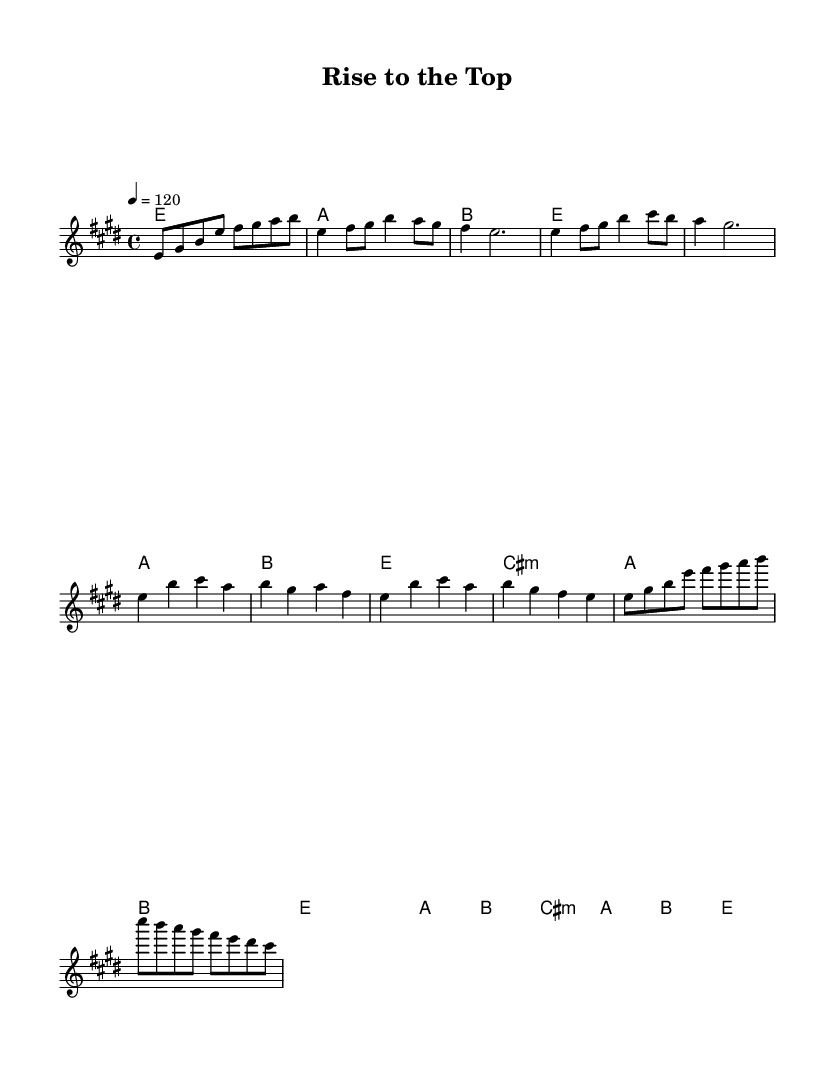What is the key signature of this music? The key signature is E major, which includes four sharps: F#, C#, G#, and D#.
Answer: E major What is the time signature of this music? The time signature is 4/4, indicating there are four beats per measure.
Answer: 4/4 What is the tempo marking of the piece? The tempo marking is Quarter note = 120, indicating a moderate pace.
Answer: 120 What is the first chord of the melody? The first chord indicated in the harmonies is E major, which is denoted as e1 in the chord mode.
Answer: E major How many notes are in the chorus? The chorus consists of eight distinct notes in the melody line before the harmonies repeat.
Answer: Eight What is the relationship between the verse and the chorus sections? The verse leads into the chorus, sharing similar chords but differing in melodic structure, indicating a contrast in energy.
Answer: Contrast Which musical term describes the recurring section in this composition? The recurring section of the composition is called the chorus, as it repeats after each verse, emphasizing the main message of perseverance.
Answer: Chorus 